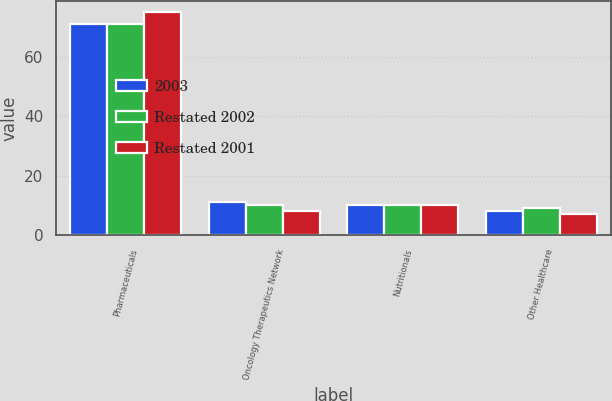Convert chart. <chart><loc_0><loc_0><loc_500><loc_500><stacked_bar_chart><ecel><fcel>Pharmaceuticals<fcel>Oncology Therapeutics Network<fcel>Nutritionals<fcel>Other Healthcare<nl><fcel>2003<fcel>71<fcel>11<fcel>10<fcel>8<nl><fcel>Restated 2002<fcel>71<fcel>10<fcel>10<fcel>9<nl><fcel>Restated 2001<fcel>75<fcel>8<fcel>10<fcel>7<nl></chart> 